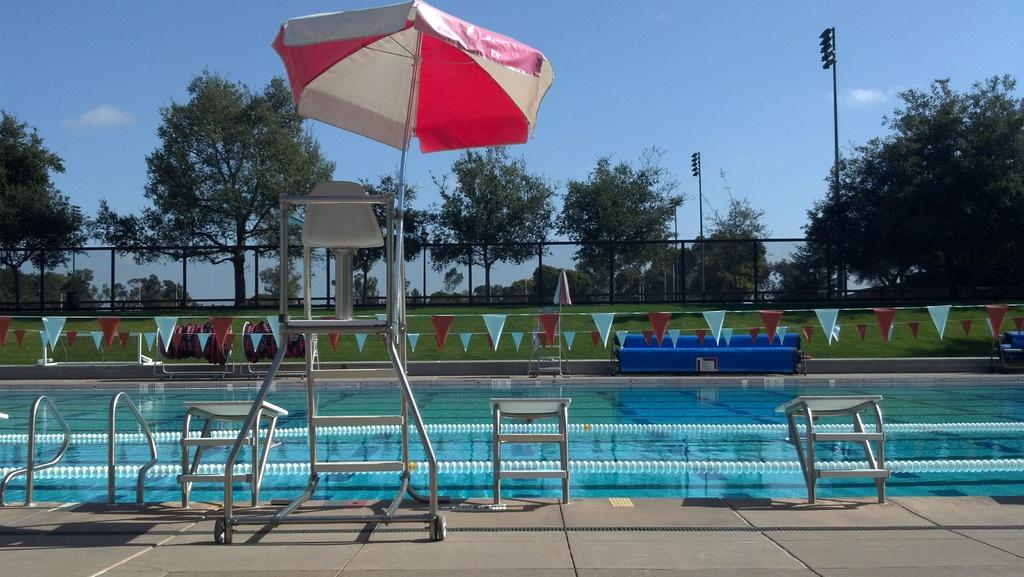What type of water feature is present in the image? There is a swimming pool in the image. What type of shade is provided in the image? There is an umbrella in the image. What type of illumination is present in the image? There are lights in the image. What type of vegetation is present in the image? There is grass and trees in the image. What is visible at the top of the image? The sky is visible at the top of the image. How many frogs are sitting on the cloth in the image? There are no frogs or cloth present in the image. What type of fight is taking place in the image? There is no fight present in the image. 